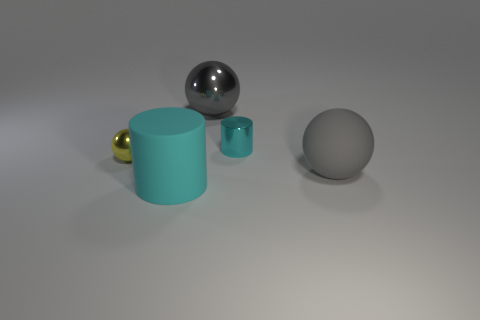Are there any metallic objects behind the tiny metallic thing right of the yellow metallic object?
Your answer should be very brief. Yes. What material is the ball that is both to the right of the yellow metal thing and behind the gray rubber ball?
Provide a succinct answer. Metal. What color is the cylinder behind the thing on the left side of the cyan object in front of the yellow shiny sphere?
Offer a terse response. Cyan. What is the color of the other thing that is the same size as the yellow object?
Provide a short and direct response. Cyan. There is a large metallic thing; does it have the same color as the big matte object behind the rubber cylinder?
Provide a short and direct response. Yes. What material is the big cylinder that is on the left side of the small metal thing behind the yellow shiny sphere?
Give a very brief answer. Rubber. What number of big gray objects are both in front of the small ball and left of the gray matte thing?
Provide a short and direct response. 0. What number of other things are there of the same size as the yellow metallic ball?
Your answer should be compact. 1. There is a big rubber thing that is right of the cyan matte cylinder; is it the same shape as the tiny metallic thing to the left of the large cyan thing?
Offer a very short reply. Yes. There is a big rubber sphere; are there any big rubber objects left of it?
Your response must be concise. Yes. 